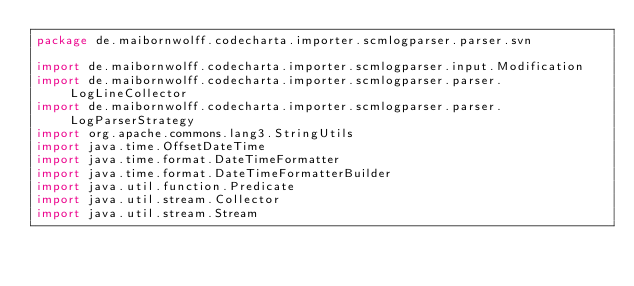Convert code to text. <code><loc_0><loc_0><loc_500><loc_500><_Kotlin_>package de.maibornwolff.codecharta.importer.scmlogparser.parser.svn

import de.maibornwolff.codecharta.importer.scmlogparser.input.Modification
import de.maibornwolff.codecharta.importer.scmlogparser.parser.LogLineCollector
import de.maibornwolff.codecharta.importer.scmlogparser.parser.LogParserStrategy
import org.apache.commons.lang3.StringUtils
import java.time.OffsetDateTime
import java.time.format.DateTimeFormatter
import java.time.format.DateTimeFormatterBuilder
import java.util.function.Predicate
import java.util.stream.Collector
import java.util.stream.Stream
</code> 